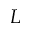<formula> <loc_0><loc_0><loc_500><loc_500>L</formula> 